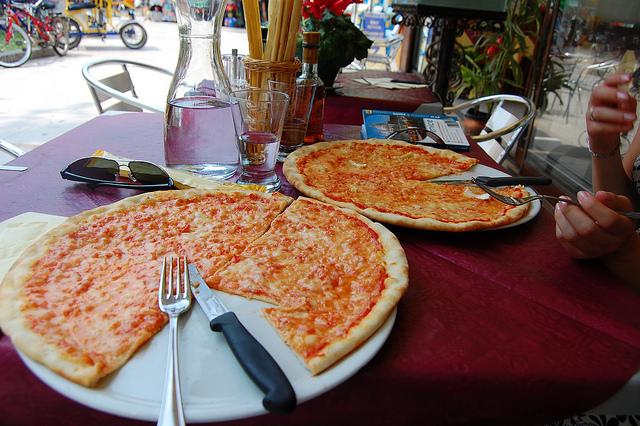What is being used to eat the pizza?
Keep it brief. Fork and knife. What is in the carafe?
Short answer required. Water. What is in the glass?
Quick response, please. Water. How many hands are in the image?
Answer briefly. 2. 